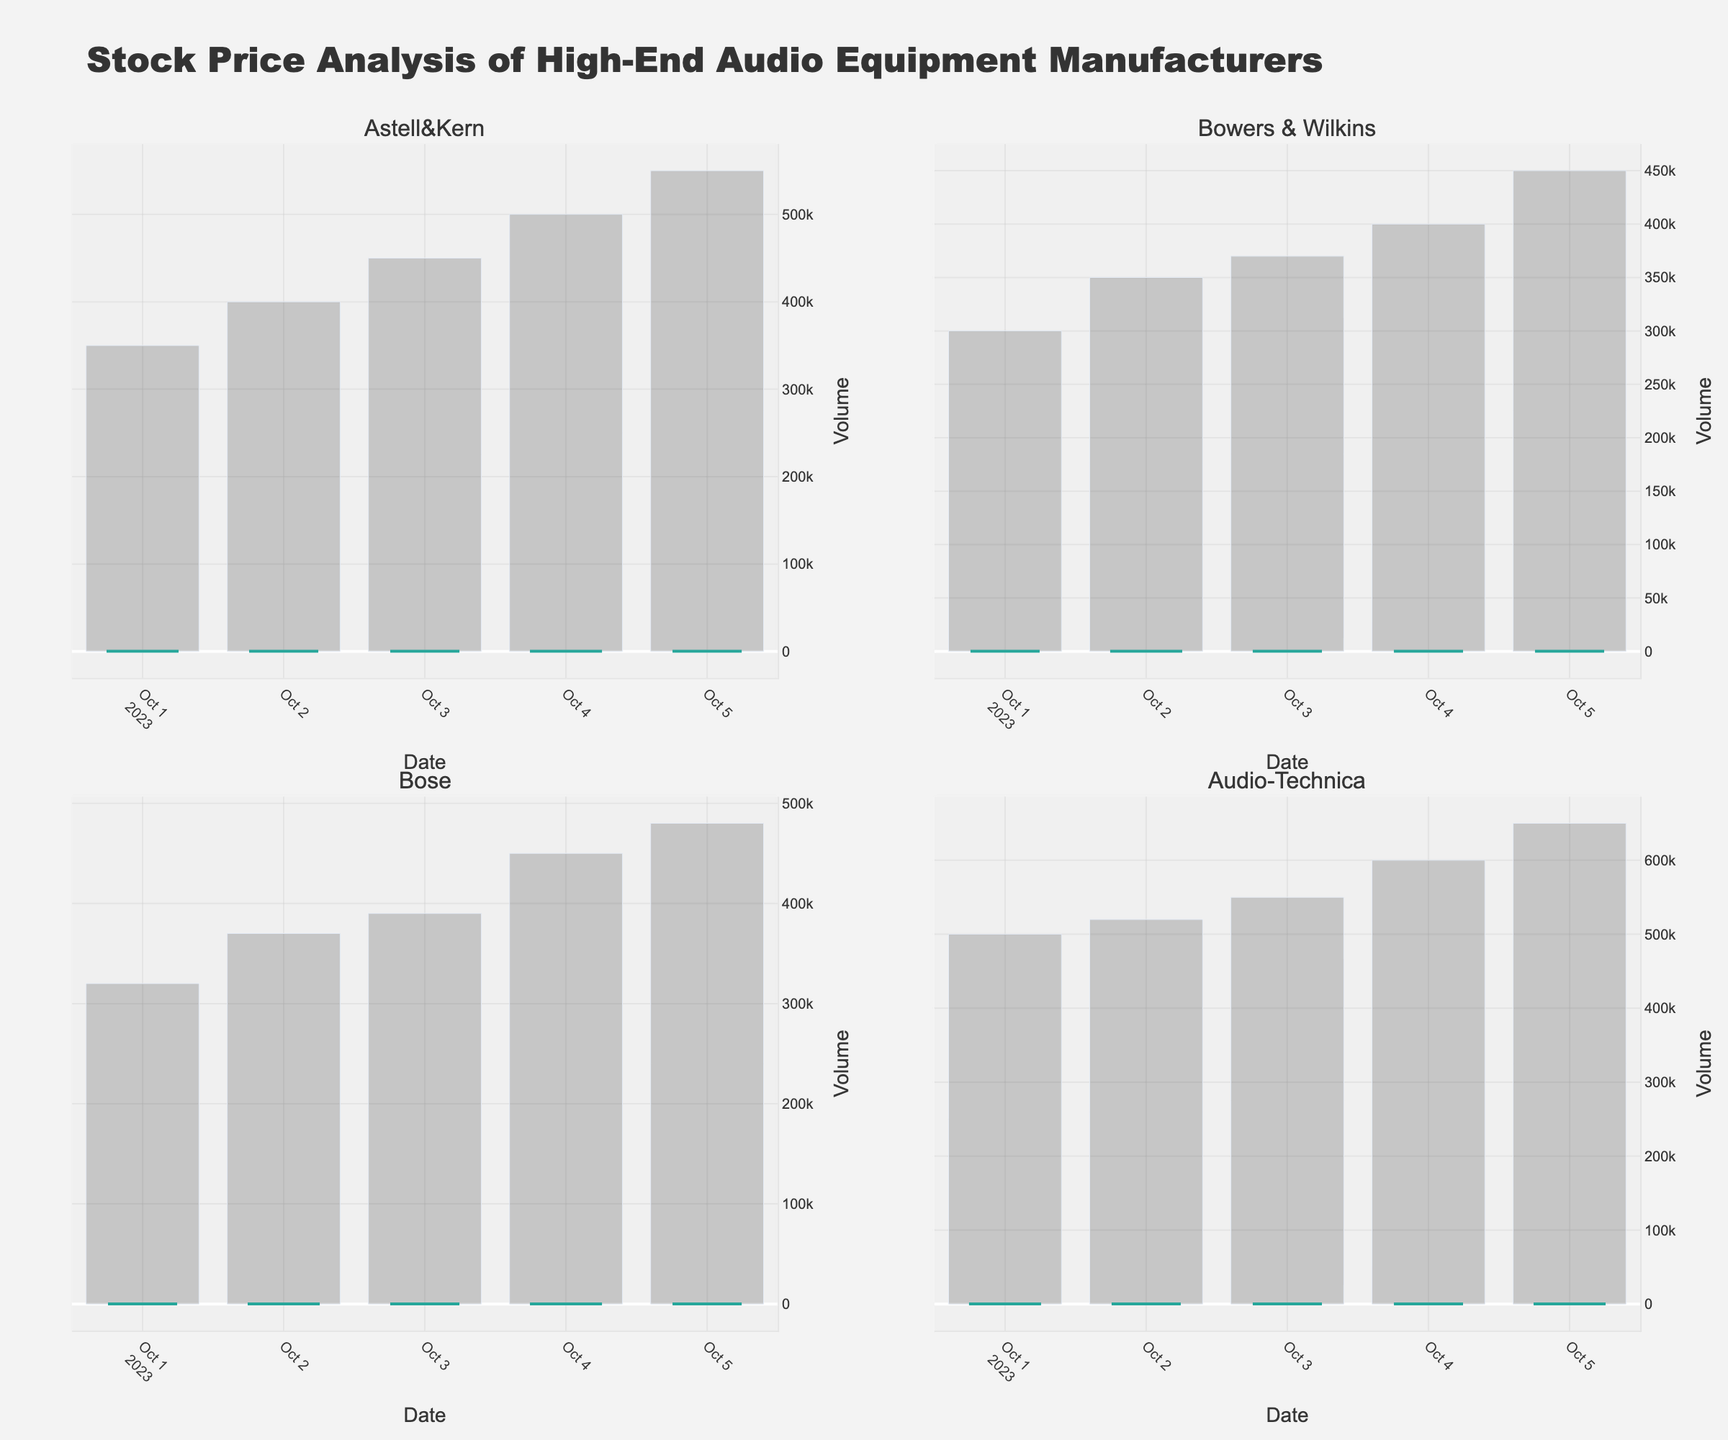What is the average closing price of Astell&Kern across the dates shown? To find the average closing price, sum up all the closing prices for Astell&Kern and then divide by the number of data points. The closing prices are 255.00, 258.00, 265.00, 270.00, 275.00. The sum is 1323.00, so the average is 1323.00 / 5 = 264.60
Answer: 264.60 Which company had the highest closing price on October 4th, 2023? To determine this, compare the closing prices on October 4th for all companies. For Astell&Kern it is 270.00, for Bowers & Wilkins it is 160.00, for Bose it is 218.00, and for Audio-Technica it is 320.00. Audio-Technica has the highest closing price.
Answer: Audio-Technica Which company experienced the largest volume of trades on October 5th, 2023? Compare the trade volumes on October 5th for all companies. Astell&Kern has 550000, Bowers & Wilkins has 450000, Bose has 480000, and Audio-Technica has 650000. Audio-Technica experienced the largest volume of trades.
Answer: Audio-Technica Did any company have a steady increase in closing prices from October 1st to October 5th, 2023? Check the closing prices each day for each company. Astell&Kern: 255.00, 258.00, 265.00, 270.00, 275.00. Bowers & Wilkins: 150.00, 153.00, 155.00, 160.00, 165.00. Bose: 202.00, 208.00, 210.00, 218.00, 222.00. Audio-Technica: 305.00, 310.00, 318.00, 320.00, 325.00. All companies show a steady increase.
Answer: Yes Which company had the smallest range (difference between High and Low) on October 2nd, 2023? Calculate the range (High - Low) for each company on October 2nd. Astell&Kern: 265.00 - 250.00 = 15.00, Bowers & Wilkins: 158.00 - 148.00 = 10.00, Bose: 210.00 - 200.00 = 10.00, Audio-Technica: 315.00 - 300.00 = 15.00. Both Bowers & Wilkins and Bose have the smallest range of 10.00.
Answer: Bowers & Wilkins and Bose What is the percentage increase in the closing price of Bose from October 1st to October 5th, 2023? Calculate the percentage increase: ((Closing price on Oct 5th - Closing price on Oct 1st) / Closing price on Oct 1st) * 100. For Bose, the closing prices are 202.00 and 222.00. The calculation is ((222.00 - 202.00) / 202.00) * 100 ≈ 9.90%.
Answer: 9.90% Which company had the highest opening price on October 3rd, 2023? Compare the opening prices on October 3rd for all companies. Astell&Kern: 258.00, Bowers & Wilkins: 153.00, Bose: 208.00, Audio-Technica: 310.00. Audio-Technica had the highest opening price.
Answer: Audio-Technica How many companies showed an increase in the closing price on October 5th compared to October 1st? Compare the closing prices on October 1st and October 5th for each company. Astell&Kern: 255.00 to 275.00 (increase), Bowers & Wilkins: 150.00 to 165.00 (increase), Bose: 202.00 to 222.00 (increase), Audio-Technica: 305.00 to 325.00 (increase). All four companies showed an increase.
Answer: 4 